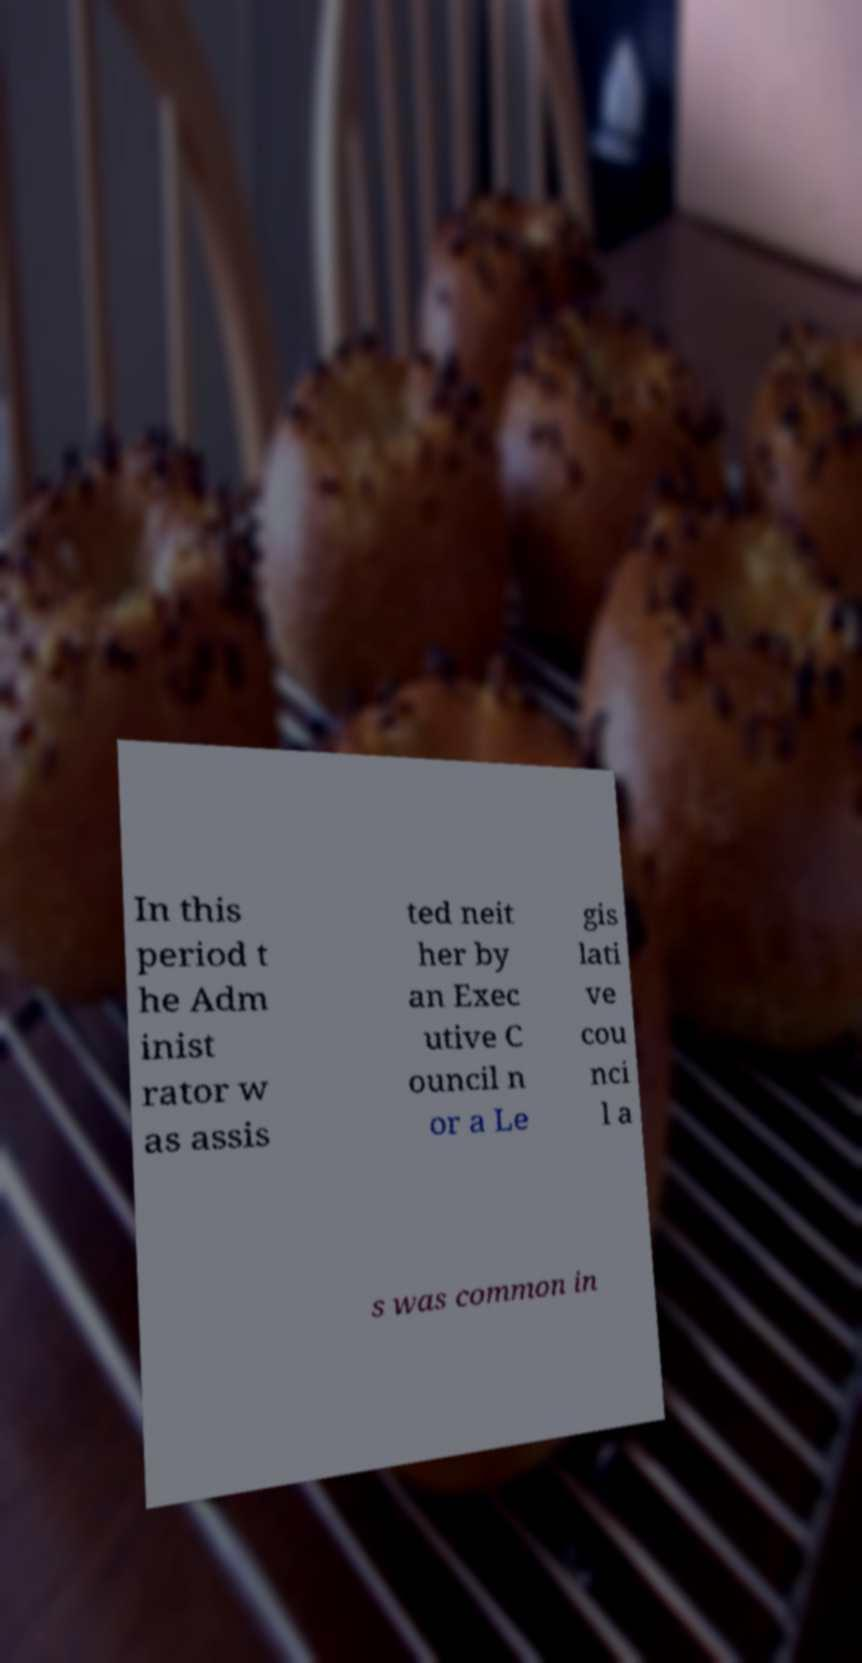Can you accurately transcribe the text from the provided image for me? In this period t he Adm inist rator w as assis ted neit her by an Exec utive C ouncil n or a Le gis lati ve cou nci l a s was common in 